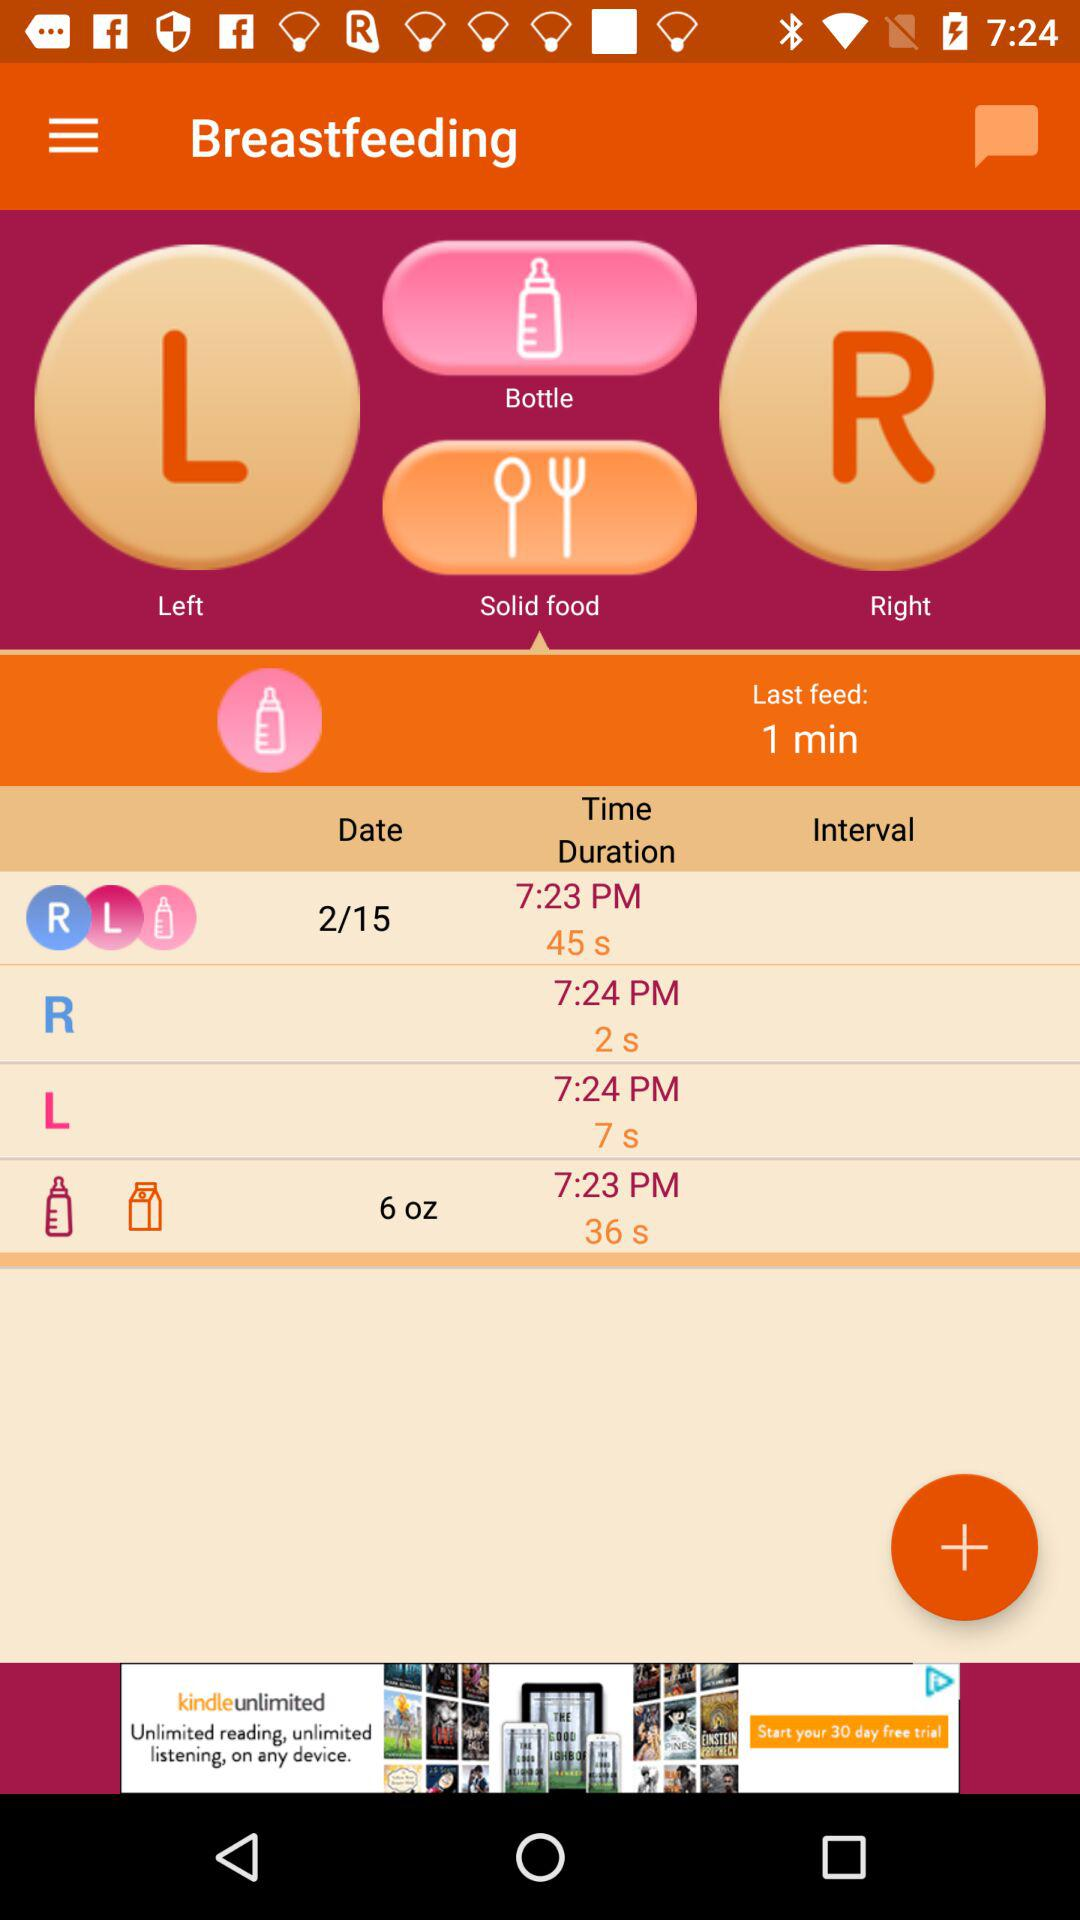How long ago was the last feed? The last feed was done 1 minute ago. 